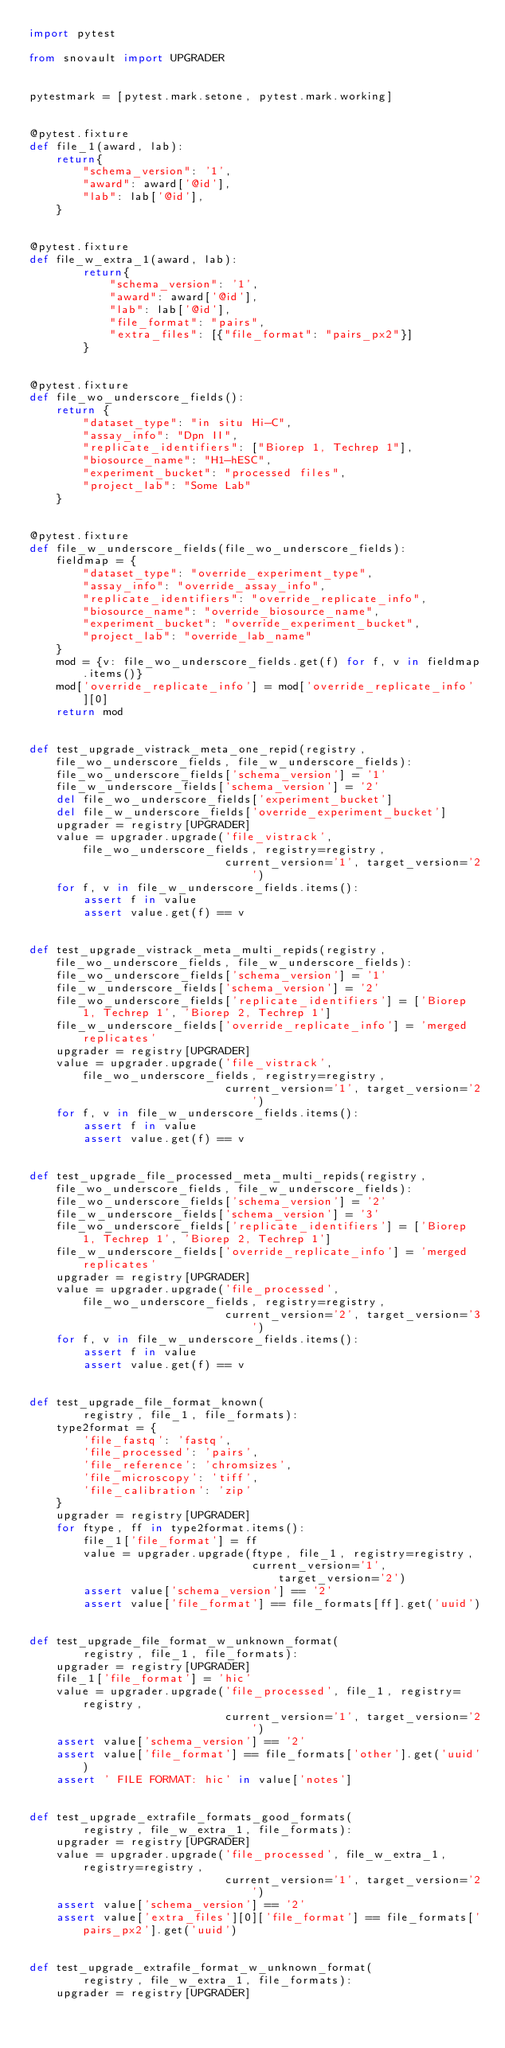Convert code to text. <code><loc_0><loc_0><loc_500><loc_500><_Python_>import pytest

from snovault import UPGRADER


pytestmark = [pytest.mark.setone, pytest.mark.working]


@pytest.fixture
def file_1(award, lab):
    return{
        "schema_version": '1',
        "award": award['@id'],
        "lab": lab['@id'],
    }


@pytest.fixture
def file_w_extra_1(award, lab):
        return{
            "schema_version": '1',
            "award": award['@id'],
            "lab": lab['@id'],
            "file_format": "pairs",
            "extra_files": [{"file_format": "pairs_px2"}]
        }


@pytest.fixture
def file_wo_underscore_fields():
    return {
        "dataset_type": "in situ Hi-C",
        "assay_info": "Dpn II",
        "replicate_identifiers": ["Biorep 1, Techrep 1"],
        "biosource_name": "H1-hESC",
        "experiment_bucket": "processed files",
        "project_lab": "Some Lab"
    }


@pytest.fixture
def file_w_underscore_fields(file_wo_underscore_fields):
    fieldmap = {
        "dataset_type": "override_experiment_type",
        "assay_info": "override_assay_info",
        "replicate_identifiers": "override_replicate_info",
        "biosource_name": "override_biosource_name",
        "experiment_bucket": "override_experiment_bucket",
        "project_lab": "override_lab_name"
    }
    mod = {v: file_wo_underscore_fields.get(f) for f, v in fieldmap.items()}
    mod['override_replicate_info'] = mod['override_replicate_info'][0]
    return mod


def test_upgrade_vistrack_meta_one_repid(registry, file_wo_underscore_fields, file_w_underscore_fields):
    file_wo_underscore_fields['schema_version'] = '1'
    file_w_underscore_fields['schema_version'] = '2'
    del file_wo_underscore_fields['experiment_bucket']
    del file_w_underscore_fields['override_experiment_bucket']
    upgrader = registry[UPGRADER]
    value = upgrader.upgrade('file_vistrack', file_wo_underscore_fields, registry=registry,
                             current_version='1', target_version='2')
    for f, v in file_w_underscore_fields.items():
        assert f in value
        assert value.get(f) == v


def test_upgrade_vistrack_meta_multi_repids(registry, file_wo_underscore_fields, file_w_underscore_fields):
    file_wo_underscore_fields['schema_version'] = '1'
    file_w_underscore_fields['schema_version'] = '2'
    file_wo_underscore_fields['replicate_identifiers'] = ['Biorep 1, Techrep 1', 'Biorep 2, Techrep 1']
    file_w_underscore_fields['override_replicate_info'] = 'merged replicates'
    upgrader = registry[UPGRADER]
    value = upgrader.upgrade('file_vistrack', file_wo_underscore_fields, registry=registry,
                             current_version='1', target_version='2')
    for f, v in file_w_underscore_fields.items():
        assert f in value
        assert value.get(f) == v


def test_upgrade_file_processed_meta_multi_repids(registry, file_wo_underscore_fields, file_w_underscore_fields):
    file_wo_underscore_fields['schema_version'] = '2'
    file_w_underscore_fields['schema_version'] = '3'
    file_wo_underscore_fields['replicate_identifiers'] = ['Biorep 1, Techrep 1', 'Biorep 2, Techrep 1']
    file_w_underscore_fields['override_replicate_info'] = 'merged replicates'
    upgrader = registry[UPGRADER]
    value = upgrader.upgrade('file_processed', file_wo_underscore_fields, registry=registry,
                             current_version='2', target_version='3')
    for f, v in file_w_underscore_fields.items():
        assert f in value
        assert value.get(f) == v


def test_upgrade_file_format_known(
        registry, file_1, file_formats):
    type2format = {
        'file_fastq': 'fastq',
        'file_processed': 'pairs',
        'file_reference': 'chromsizes',
        'file_microscopy': 'tiff',
        'file_calibration': 'zip'
    }
    upgrader = registry[UPGRADER]
    for ftype, ff in type2format.items():
        file_1['file_format'] = ff
        value = upgrader.upgrade(ftype, file_1, registry=registry,
                                 current_version='1', target_version='2')
        assert value['schema_version'] == '2'
        assert value['file_format'] == file_formats[ff].get('uuid')


def test_upgrade_file_format_w_unknown_format(
        registry, file_1, file_formats):
    upgrader = registry[UPGRADER]
    file_1['file_format'] = 'hic'
    value = upgrader.upgrade('file_processed', file_1, registry=registry,
                             current_version='1', target_version='2')
    assert value['schema_version'] == '2'
    assert value['file_format'] == file_formats['other'].get('uuid')
    assert ' FILE FORMAT: hic' in value['notes']


def test_upgrade_extrafile_formats_good_formats(
        registry, file_w_extra_1, file_formats):
    upgrader = registry[UPGRADER]
    value = upgrader.upgrade('file_processed', file_w_extra_1, registry=registry,
                             current_version='1', target_version='2')
    assert value['schema_version'] == '2'
    assert value['extra_files'][0]['file_format'] == file_formats['pairs_px2'].get('uuid')


def test_upgrade_extrafile_format_w_unknown_format(
        registry, file_w_extra_1, file_formats):
    upgrader = registry[UPGRADER]</code> 